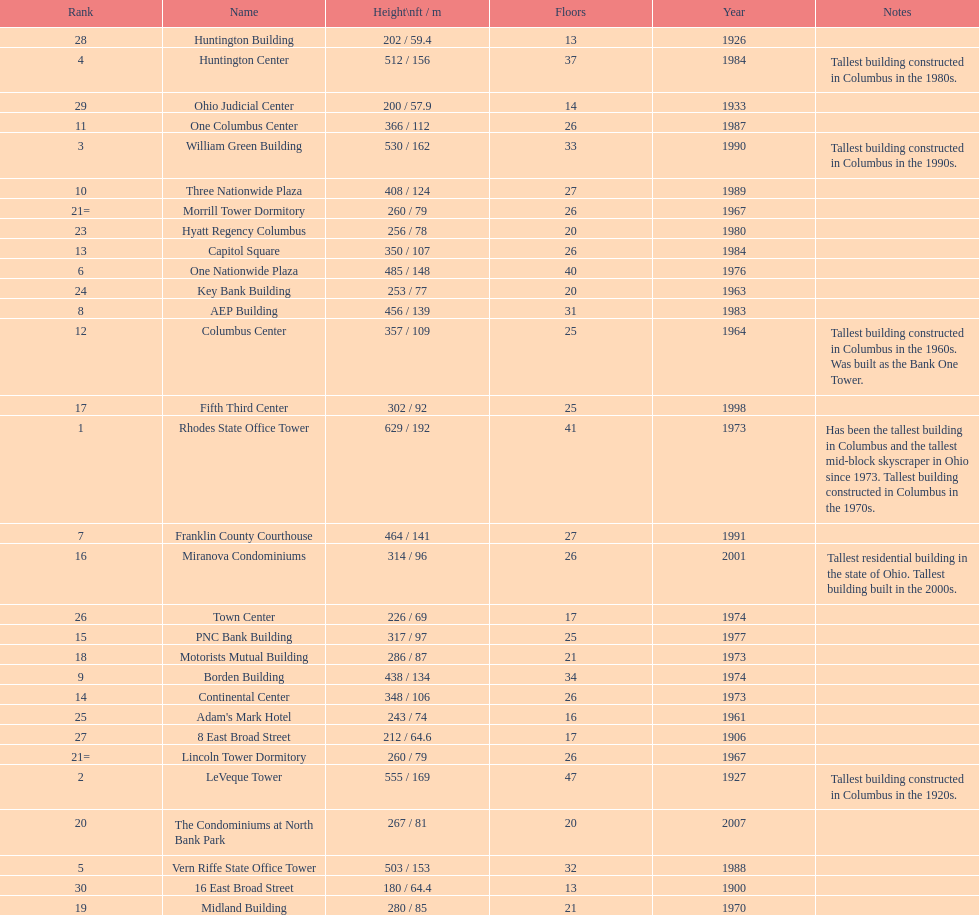What is the number of buildings under 200 ft? 1. 